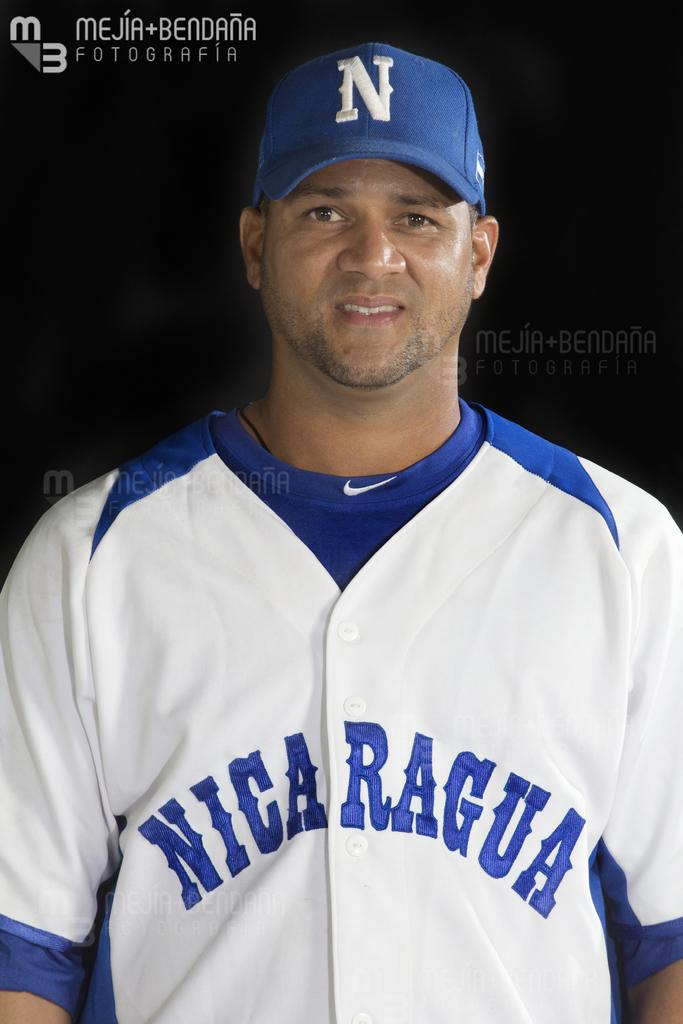Provide a one-sentence caption for the provided image. A baseball player from Nicaragua appears in uniform. 